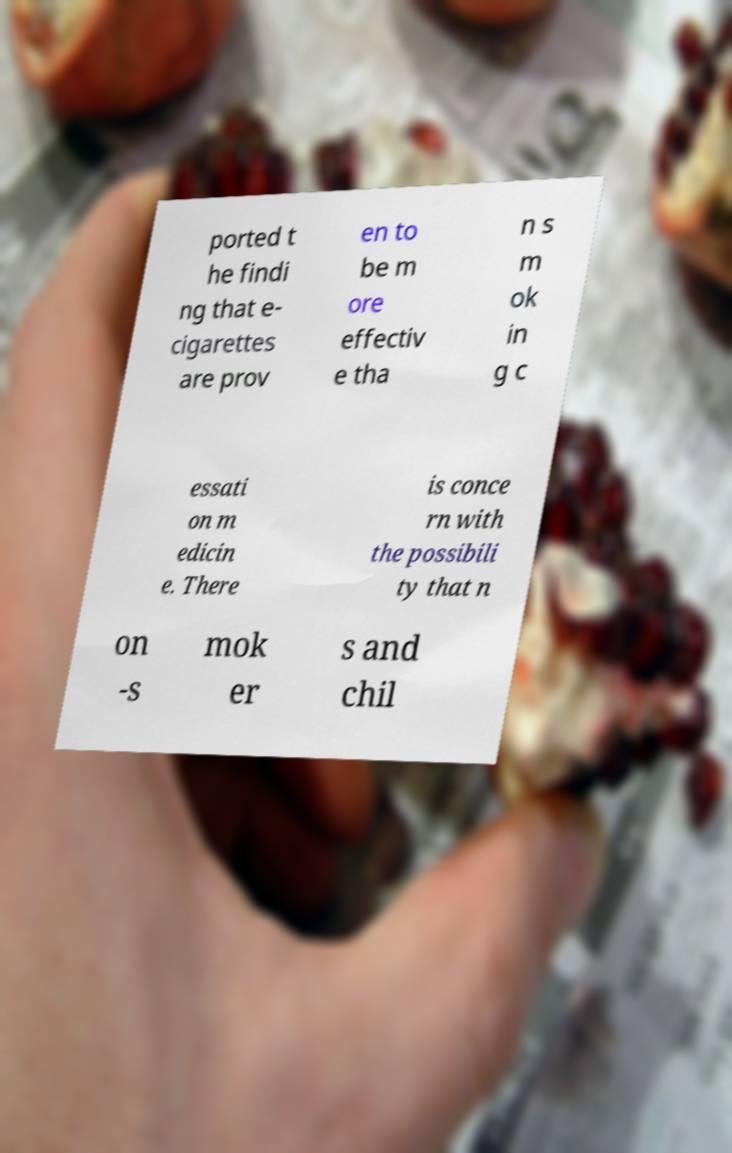Could you extract and type out the text from this image? ported t he findi ng that e- cigarettes are prov en to be m ore effectiv e tha n s m ok in g c essati on m edicin e. There is conce rn with the possibili ty that n on -s mok er s and chil 